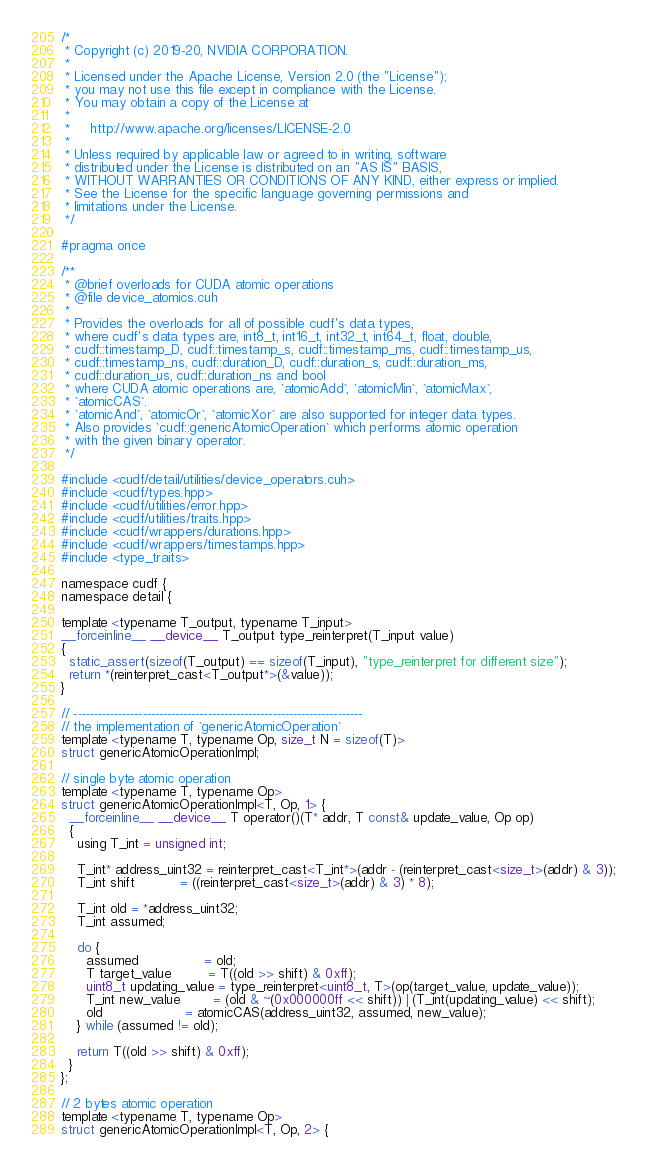<code> <loc_0><loc_0><loc_500><loc_500><_Cuda_>/*
 * Copyright (c) 2019-20, NVIDIA CORPORATION.
 *
 * Licensed under the Apache License, Version 2.0 (the "License");
 * you may not use this file except in compliance with the License.
 * You may obtain a copy of the License at
 *
 *     http://www.apache.org/licenses/LICENSE-2.0
 *
 * Unless required by applicable law or agreed to in writing, software
 * distributed under the License is distributed on an "AS IS" BASIS,
 * WITHOUT WARRANTIES OR CONDITIONS OF ANY KIND, either express or implied.
 * See the License for the specific language governing permissions and
 * limitations under the License.
 */

#pragma once

/**
 * @brief overloads for CUDA atomic operations
 * @file device_atomics.cuh
 *
 * Provides the overloads for all of possible cudf's data types,
 * where cudf's data types are, int8_t, int16_t, int32_t, int64_t, float, double,
 * cudf::timestamp_D, cudf::timestamp_s, cudf::timestamp_ms, cudf::timestamp_us,
 * cudf::timestamp_ns, cudf::duration_D, cudf::duration_s, cudf::duration_ms,
 * cudf::duration_us, cudf::duration_ns and bool
 * where CUDA atomic operations are, `atomicAdd`, `atomicMin`, `atomicMax`,
 * `atomicCAS`.
 * `atomicAnd`, `atomicOr`, `atomicXor` are also supported for integer data types.
 * Also provides `cudf::genericAtomicOperation` which performs atomic operation
 * with the given binary operator.
 */

#include <cudf/detail/utilities/device_operators.cuh>
#include <cudf/types.hpp>
#include <cudf/utilities/error.hpp>
#include <cudf/utilities/traits.hpp>
#include <cudf/wrappers/durations.hpp>
#include <cudf/wrappers/timestamps.hpp>
#include <type_traits>

namespace cudf {
namespace detail {

template <typename T_output, typename T_input>
__forceinline__ __device__ T_output type_reinterpret(T_input value)
{
  static_assert(sizeof(T_output) == sizeof(T_input), "type_reinterpret for different size");
  return *(reinterpret_cast<T_output*>(&value));
}

// -----------------------------------------------------------------------
// the implementation of `genericAtomicOperation`
template <typename T, typename Op, size_t N = sizeof(T)>
struct genericAtomicOperationImpl;

// single byte atomic operation
template <typename T, typename Op>
struct genericAtomicOperationImpl<T, Op, 1> {
  __forceinline__ __device__ T operator()(T* addr, T const& update_value, Op op)
  {
    using T_int = unsigned int;

    T_int* address_uint32 = reinterpret_cast<T_int*>(addr - (reinterpret_cast<size_t>(addr) & 3));
    T_int shift           = ((reinterpret_cast<size_t>(addr) & 3) * 8);

    T_int old = *address_uint32;
    T_int assumed;

    do {
      assumed                = old;
      T target_value         = T((old >> shift) & 0xff);
      uint8_t updating_value = type_reinterpret<uint8_t, T>(op(target_value, update_value));
      T_int new_value        = (old & ~(0x000000ff << shift)) | (T_int(updating_value) << shift);
      old                    = atomicCAS(address_uint32, assumed, new_value);
    } while (assumed != old);

    return T((old >> shift) & 0xff);
  }
};

// 2 bytes atomic operation
template <typename T, typename Op>
struct genericAtomicOperationImpl<T, Op, 2> {</code> 